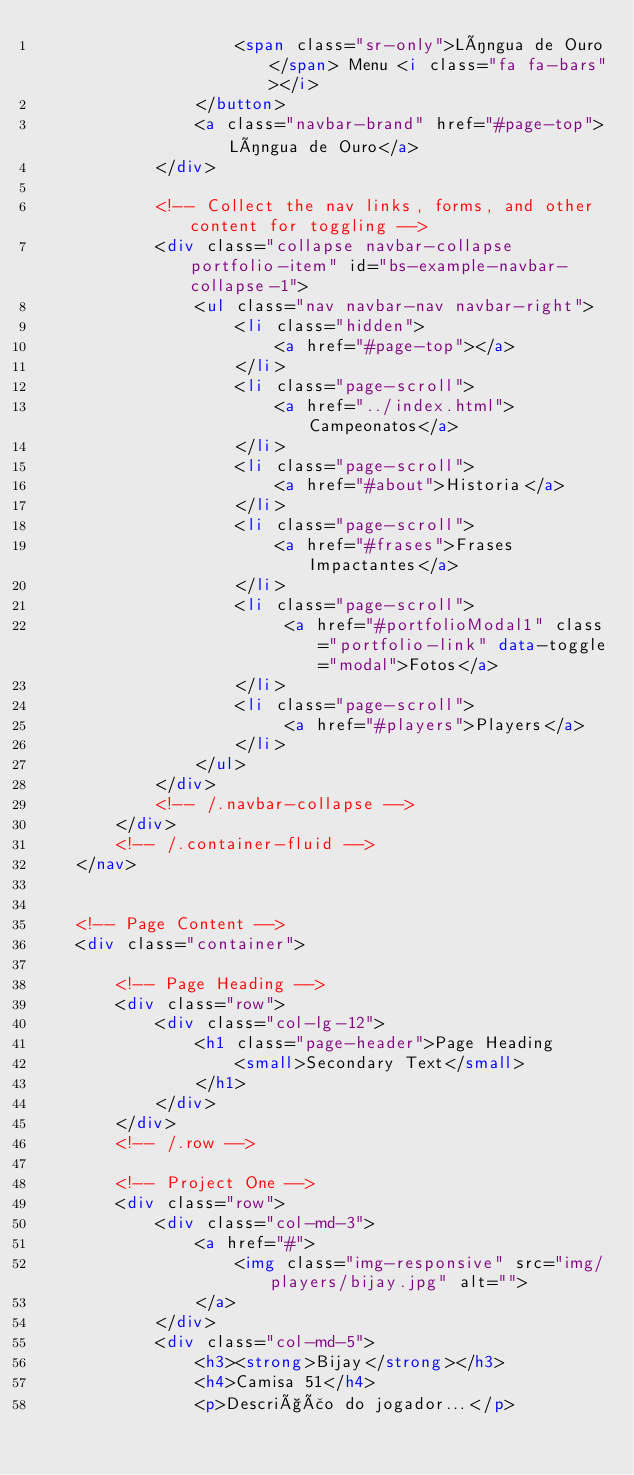<code> <loc_0><loc_0><loc_500><loc_500><_HTML_>                    <span class="sr-only">Língua de Ouro</span> Menu <i class="fa fa-bars"></i>
                </button>
                <a class="navbar-brand" href="#page-top">Língua de Ouro</a>
            </div>

            <!-- Collect the nav links, forms, and other content for toggling -->
            <div class="collapse navbar-collapse portfolio-item" id="bs-example-navbar-collapse-1">
                <ul class="nav navbar-nav navbar-right">
                    <li class="hidden">
                        <a href="#page-top"></a>
                    </li>
                    <li class="page-scroll">
                        <a href="../index.html">Campeonatos</a>
                    </li>
                    <li class="page-scroll">
                        <a href="#about">Historia</a>
                    </li>
                    <li class="page-scroll">
                        <a href="#frases">Frases Impactantes</a>
                    </li>
                    <li class="page-scroll">
                         <a href="#portfolioModal1" class="portfolio-link" data-toggle="modal">Fotos</a>
                    </li>
                    <li class="page-scroll">
                         <a href="#players">Players</a>
                    </li>                    
                </ul>
            </div>
            <!-- /.navbar-collapse -->
        </div>
        <!-- /.container-fluid -->
    </nav>


    <!-- Page Content -->
    <div class="container">

        <!-- Page Heading -->
        <div class="row">
            <div class="col-lg-12">
                <h1 class="page-header">Page Heading
                    <small>Secondary Text</small>
                </h1>
            </div>
        </div>
        <!-- /.row -->

        <!-- Project One -->
        <div class="row">
            <div class="col-md-3">
                <a href="#">
                    <img class="img-responsive" src="img/players/bijay.jpg" alt="">
                </a>
            </div>
            <div class="col-md-5">
                <h3><strong>Bijay</strong></h3>
                <h4>Camisa 51</h4>
                <p>Descrição do jogador...</p></code> 